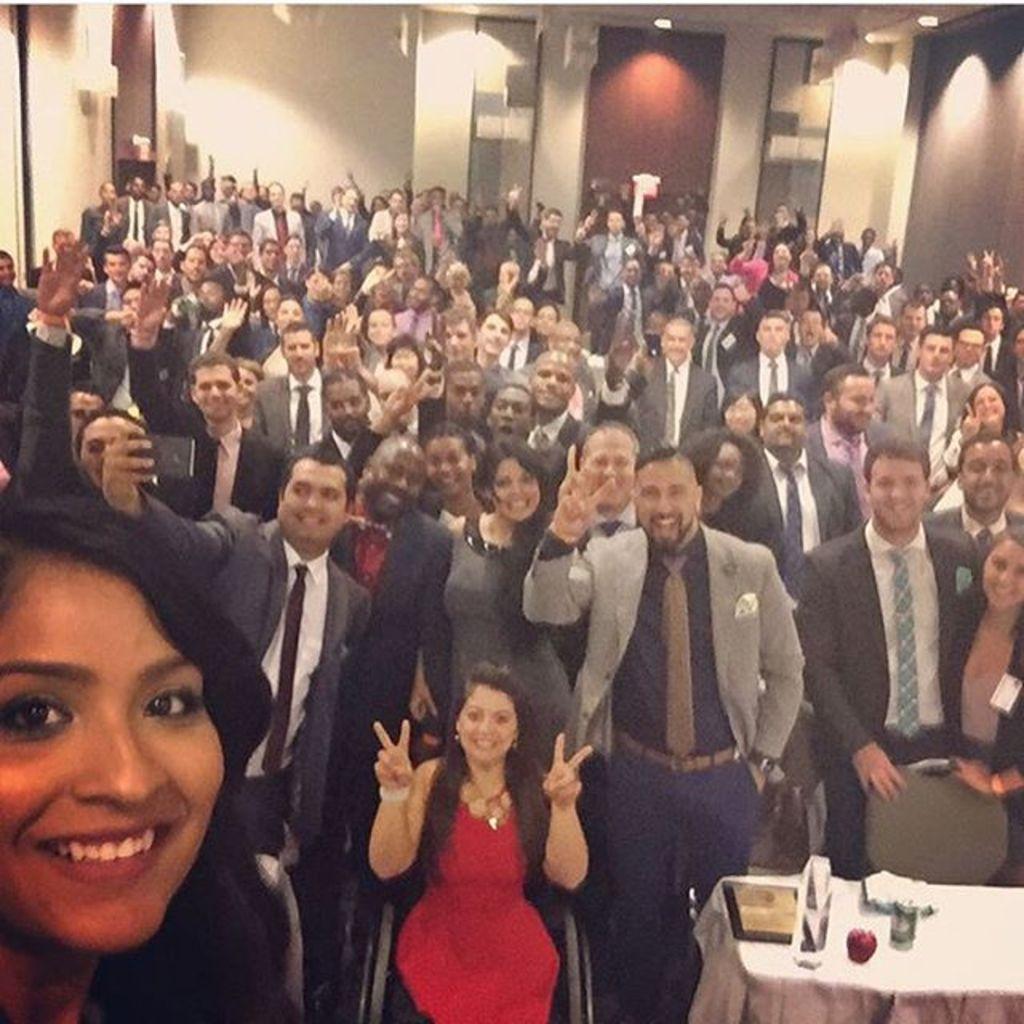In one or two sentences, can you explain what this image depicts? In the foreground of this image, on the left, there is a woman. In the background, there are many people posing to the camera, walls and lights to the ceiling. At the bottom, there is a shield, glass and few more objects on the table. 